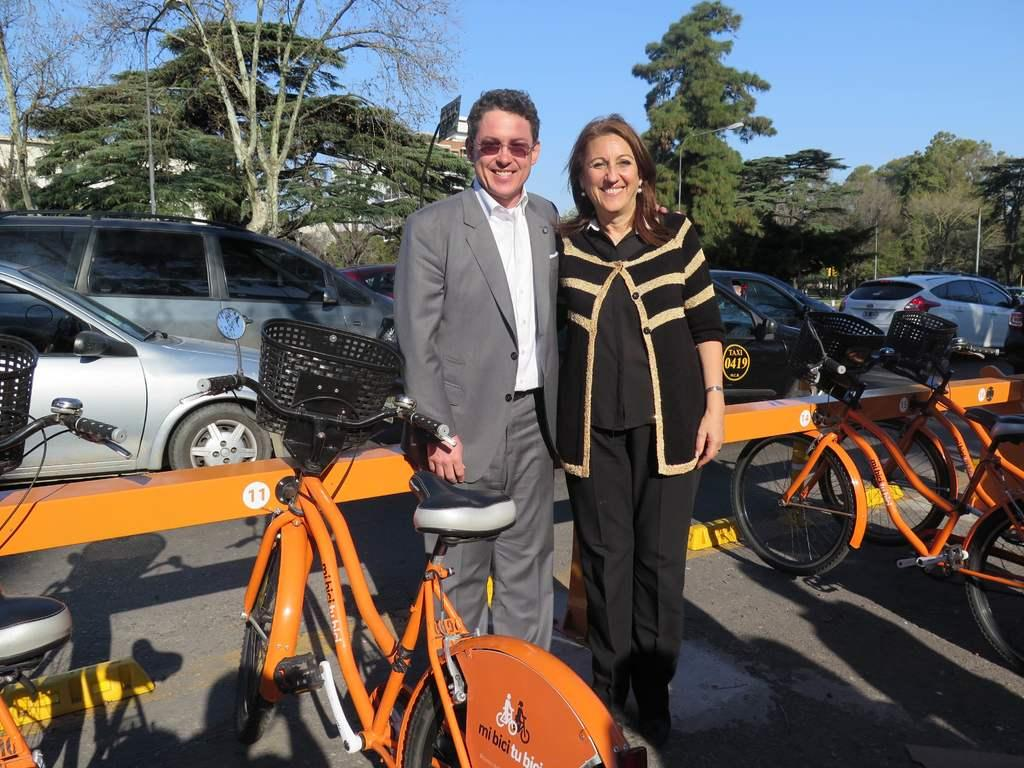Who can be seen in the image? There is a man and a woman in the image. What are the man and woman doing in the image? The man and woman are standing on the road and smiling. What type of vehicles are present in the image? There are bicycles and cars in the image. What can be seen in the background of the image? There are trees, poles, a board, a building, and the sky visible in the background of the image. What type of cabbage is being harvested in the image? There is no cabbage present in the image; it features a man and a woman standing on the road with bicycles and cars. What type of industry is depicted in the image? The image does not depict any specific industry; it shows a man and a woman standing on the road with bicycles and cars. 